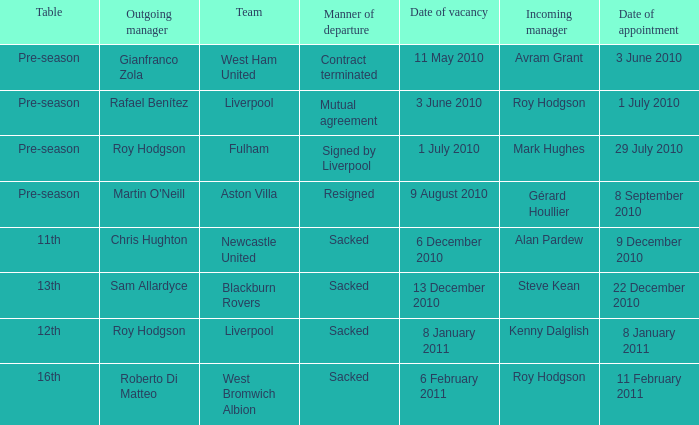What is the date of vacancy for the Liverpool team with a table named pre-season? 3 June 2010. 